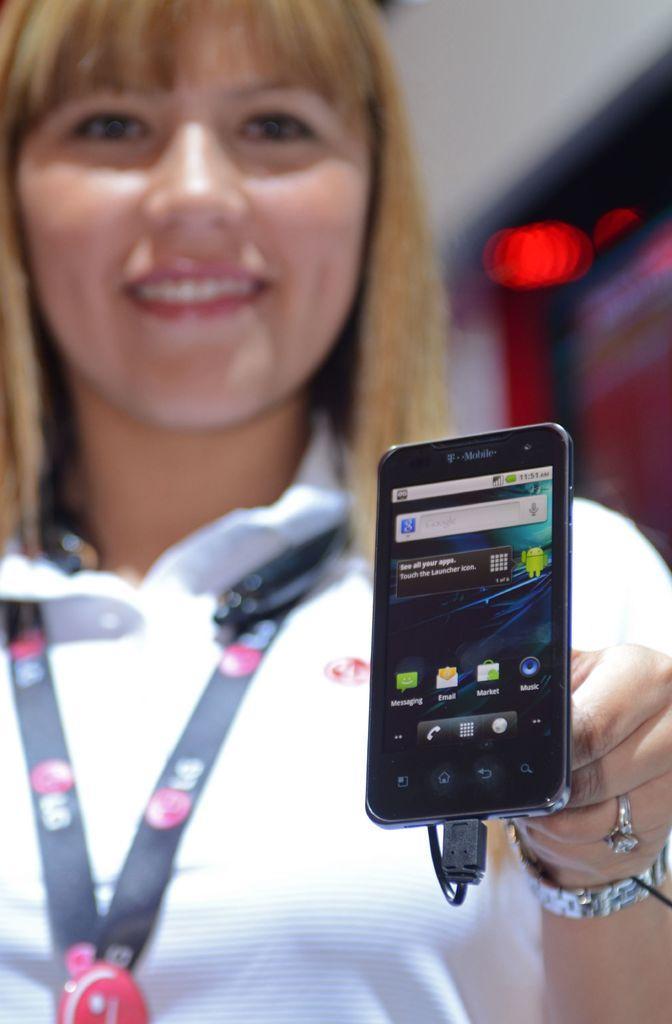Please provide a concise description of this image. In this image I can see a woman wearing a tag and holding a mobile. On the mobile screen I can see applications. In the background of the image it is blurry.  